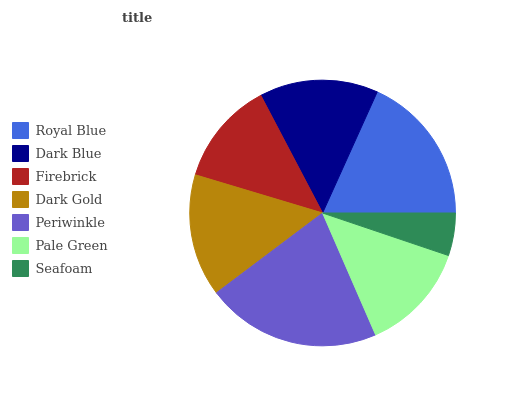Is Seafoam the minimum?
Answer yes or no. Yes. Is Periwinkle the maximum?
Answer yes or no. Yes. Is Dark Blue the minimum?
Answer yes or no. No. Is Dark Blue the maximum?
Answer yes or no. No. Is Royal Blue greater than Dark Blue?
Answer yes or no. Yes. Is Dark Blue less than Royal Blue?
Answer yes or no. Yes. Is Dark Blue greater than Royal Blue?
Answer yes or no. No. Is Royal Blue less than Dark Blue?
Answer yes or no. No. Is Dark Blue the high median?
Answer yes or no. Yes. Is Dark Blue the low median?
Answer yes or no. Yes. Is Seafoam the high median?
Answer yes or no. No. Is Periwinkle the low median?
Answer yes or no. No. 